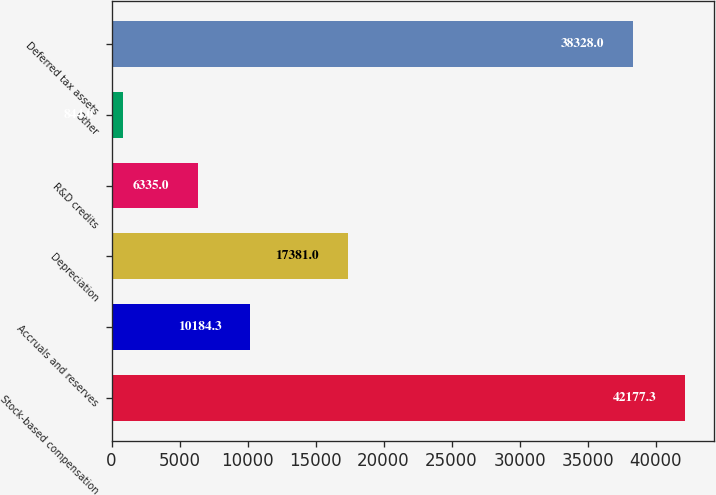Convert chart. <chart><loc_0><loc_0><loc_500><loc_500><bar_chart><fcel>Stock-based compensation<fcel>Accruals and reserves<fcel>Depreciation<fcel>R&D credits<fcel>Other<fcel>Deferred tax assets<nl><fcel>42177.3<fcel>10184.3<fcel>17381<fcel>6335<fcel>844<fcel>38328<nl></chart> 